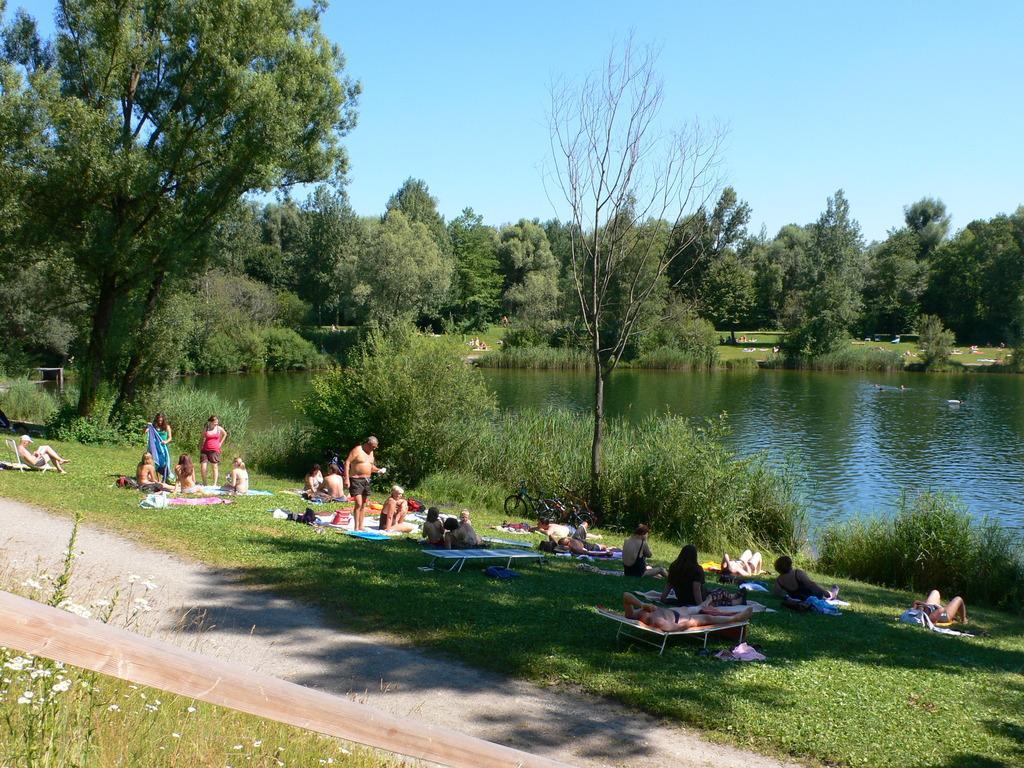Could you give a brief overview of what you see in this image? In this image I can see the group of people are on the grass. I can see few people are sitting, few people are standing and few people are lying on the bed. To the side of these people I can see the bicycles. In the background I can see many trees, water and the sky. 